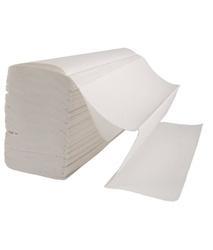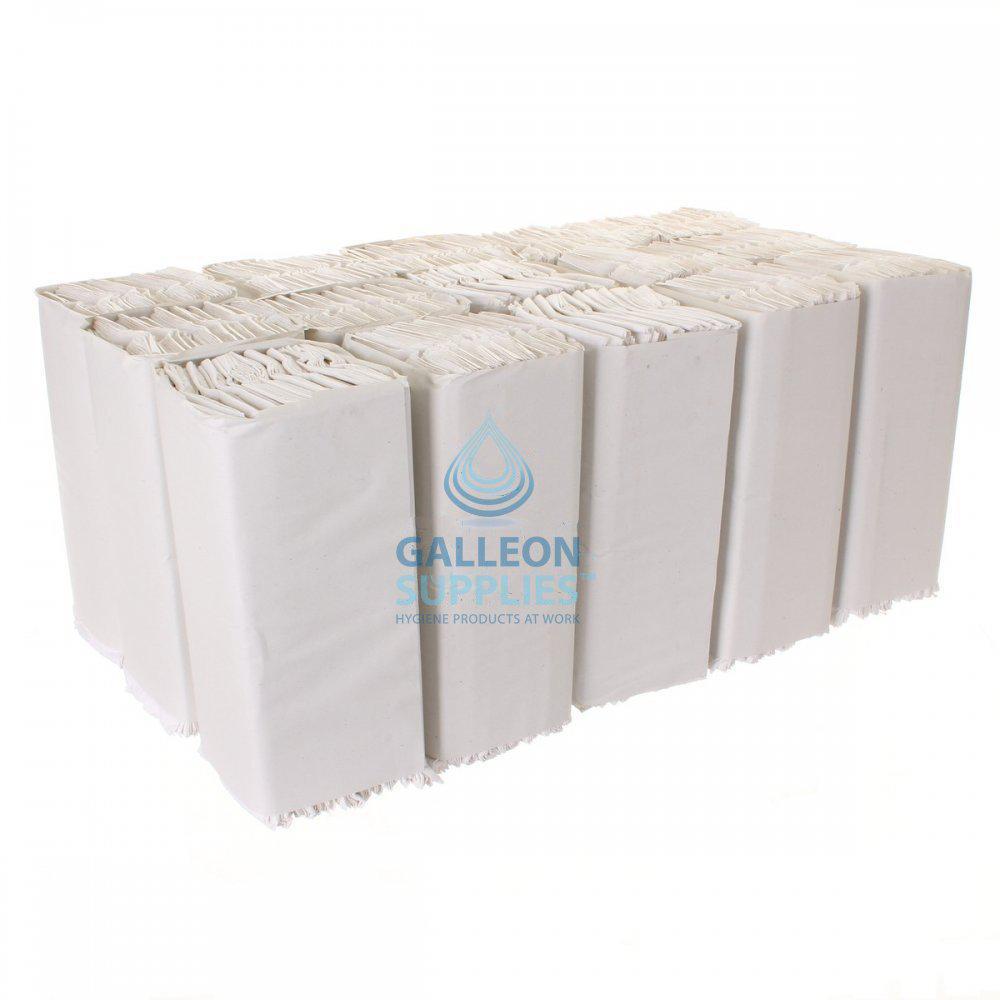The first image is the image on the left, the second image is the image on the right. Evaluate the accuracy of this statement regarding the images: "The right image contains one wrapped pack of folded paper towels, and the left image shows a single folded towel that is not aligned with a neat stack.". Is it true? Answer yes or no. No. The first image is the image on the left, the second image is the image on the right. Assess this claim about the two images: "Some paper towels are wrapped in paper.". Correct or not? Answer yes or no. Yes. 